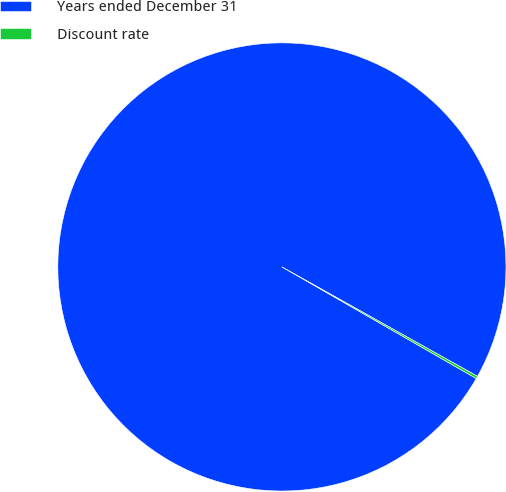<chart> <loc_0><loc_0><loc_500><loc_500><pie_chart><fcel>Years ended December 31<fcel>Discount rate<nl><fcel>99.82%<fcel>0.18%<nl></chart> 